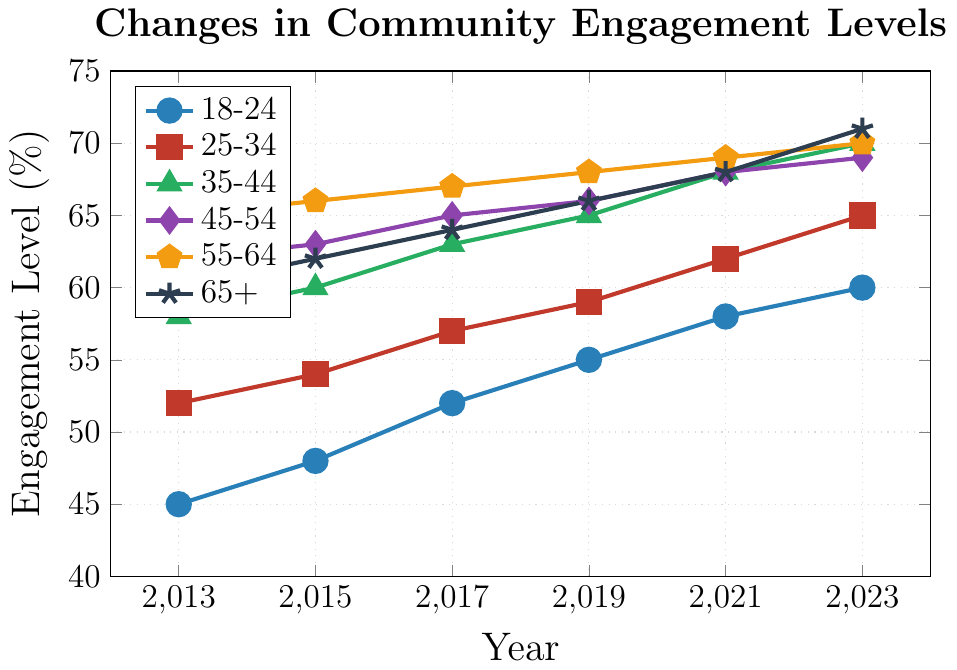Which age group had the highest community engagement level in 2023? Looking at the figure, the age group 65+ has the highest community engagement level in 2023, reaching 71%.
Answer: 65+ How did the community engagement level for the 18-24 age group change from 2013 to 2023? In 2013, the engagement level for 18-24 was 45%; by 2023, it had increased to 60%. The change is 60 - 45 = 15%.
Answer: Increased by 15% Which two age groups had the most similar community engagement levels in 2021? According to the figure, the age groups 55-64 and 65+ both had an engagement level of 68% in 2021.
Answer: 55-64 and 65+ What is the average community engagement level for the 25-34 age group over the six years shown in the chart? The engagement levels for 25-34 are 52, 54, 57, 59, 62, and 65. The sum is 52 + 54 + 57 + 59 + 62 + 65 = 349. The average is 349 / 6 ≈ 58.17%.
Answer: ≈ 58.17% Between which two successive years did the 35-44 age group see the largest increase in community engagement level? The engagement levels for 35-44 are 58, 60, 63, 65, 68, and 70. The increases are 2 (60-58), 3 (63-60), 2 (65-63), 3 (68-65), and 2 (70-68). The largest increase is 3, which occurred between 2015-2017 and 2019-2021.
Answer: 2015-2017 and 2019-2021 Which age group had consistently increasing community engagement levels across all the years in the chart? All age groups had consistently increasing engagement levels, as none of the lines decrease at any point.
Answer: All age groups In 2019, which age group had a lower engagement level than the 45-54 age group, and by how much? In 2019, the engagement level for the 45-54 age group was 66%. The 18-24 age group had 55%, which is 66 - 55 = 11% lower.
Answer: 18-24 by 11% By how much did the engagement level of the 55-64 age group increase from 2013 to 2023? The engagement level in 2013 was 65%, and in 2023 it was 70%. The increase is 70 - 65 = 5%.
Answer: Increased by 5% 